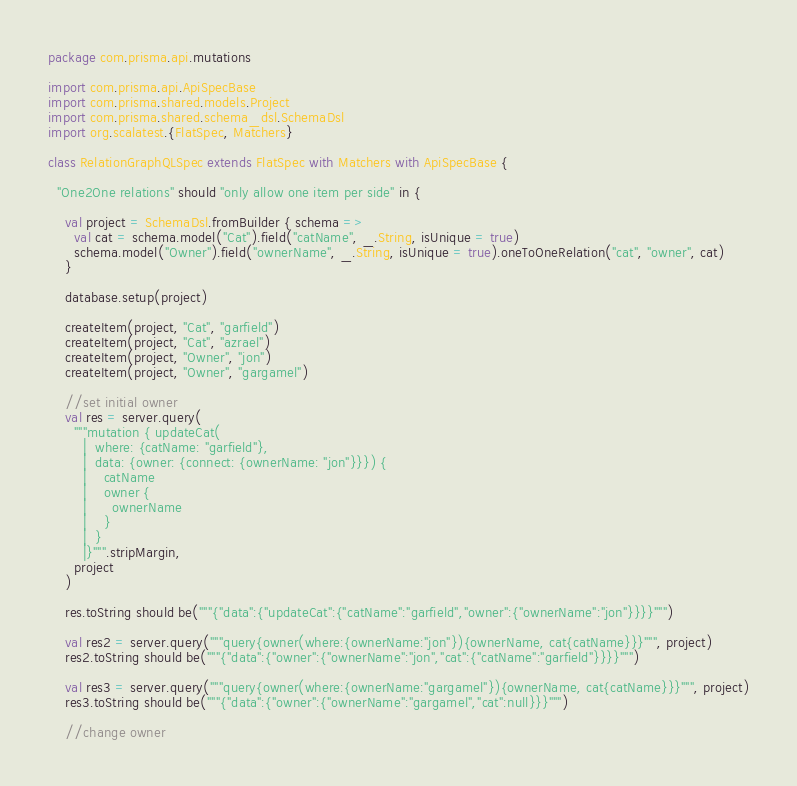<code> <loc_0><loc_0><loc_500><loc_500><_Scala_>package com.prisma.api.mutations

import com.prisma.api.ApiSpecBase
import com.prisma.shared.models.Project
import com.prisma.shared.schema_dsl.SchemaDsl
import org.scalatest.{FlatSpec, Matchers}

class RelationGraphQLSpec extends FlatSpec with Matchers with ApiSpecBase {

  "One2One relations" should "only allow one item per side" in {

    val project = SchemaDsl.fromBuilder { schema =>
      val cat = schema.model("Cat").field("catName", _.String, isUnique = true)
      schema.model("Owner").field("ownerName", _.String, isUnique = true).oneToOneRelation("cat", "owner", cat)
    }

    database.setup(project)

    createItem(project, "Cat", "garfield")
    createItem(project, "Cat", "azrael")
    createItem(project, "Owner", "jon")
    createItem(project, "Owner", "gargamel")

    //set initial owner
    val res = server.query(
      """mutation { updateCat(
        |  where: {catName: "garfield"},
        |  data: {owner: {connect: {ownerName: "jon"}}}) {
        |    catName
        |    owner {
        |      ownerName
        |    }
        |  }
        |}""".stripMargin,
      project
    )

    res.toString should be("""{"data":{"updateCat":{"catName":"garfield","owner":{"ownerName":"jon"}}}}""")

    val res2 = server.query("""query{owner(where:{ownerName:"jon"}){ownerName, cat{catName}}}""", project)
    res2.toString should be("""{"data":{"owner":{"ownerName":"jon","cat":{"catName":"garfield"}}}}""")

    val res3 = server.query("""query{owner(where:{ownerName:"gargamel"}){ownerName, cat{catName}}}""", project)
    res3.toString should be("""{"data":{"owner":{"ownerName":"gargamel","cat":null}}}""")

    //change owner
</code> 